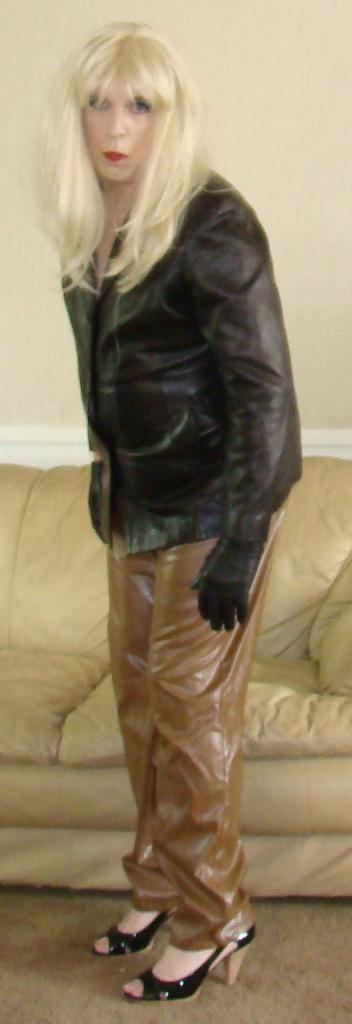Who or what is the main subject in the image? There is a person in the image. What can be observed about the person's attire? The person is wearing clothes. What piece of furniture is visible in the background? The person is standing in front of a sofa. What type of list is the person holding in the image? There is no list present in the image; the person is not holding anything. 